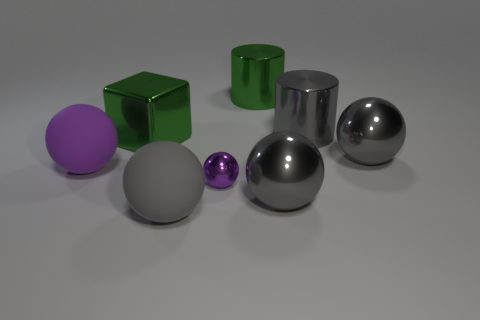There is a big shiny ball left of the sphere behind the big purple thing; what is its color? gray 